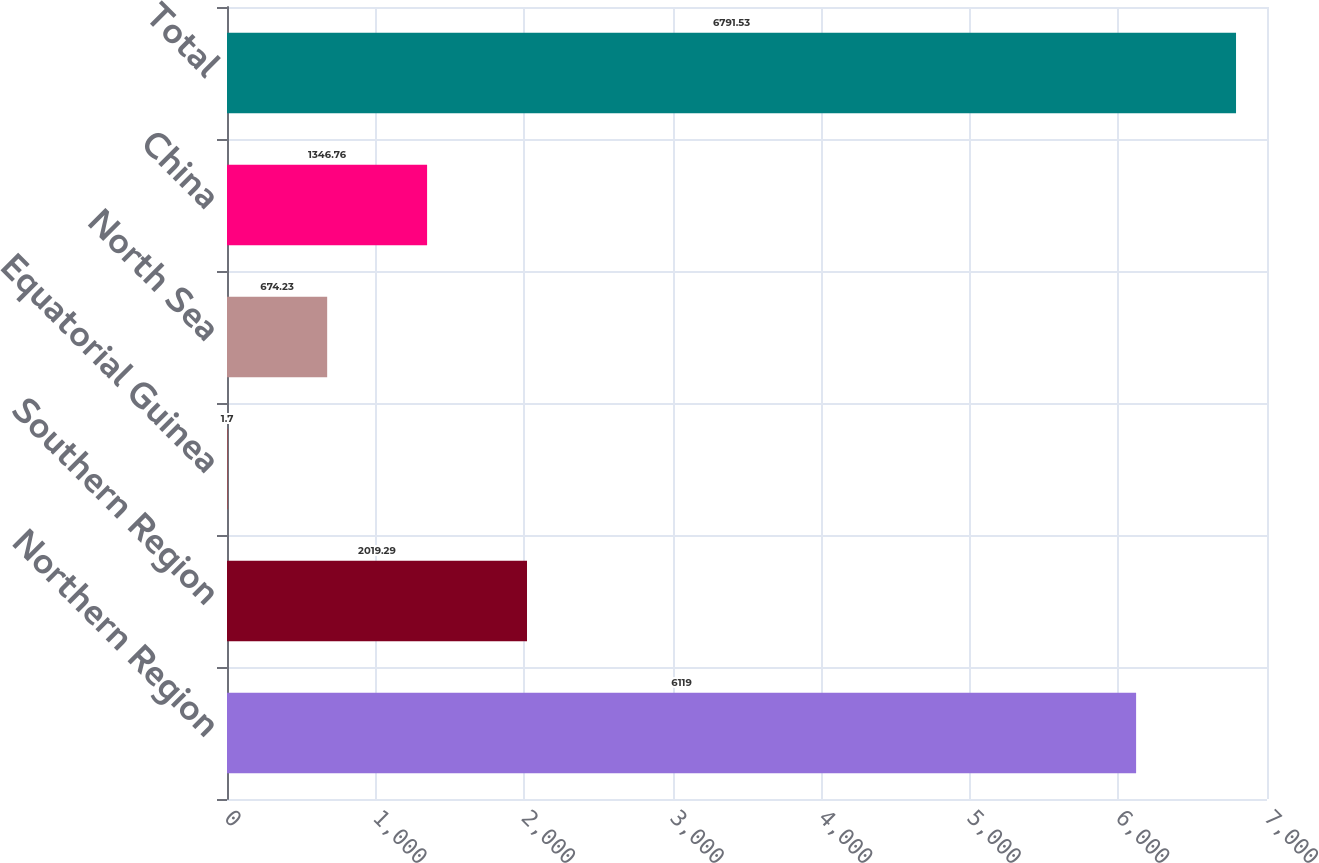Convert chart to OTSL. <chart><loc_0><loc_0><loc_500><loc_500><bar_chart><fcel>Northern Region<fcel>Southern Region<fcel>Equatorial Guinea<fcel>North Sea<fcel>China<fcel>Total<nl><fcel>6119<fcel>2019.29<fcel>1.7<fcel>674.23<fcel>1346.76<fcel>6791.53<nl></chart> 